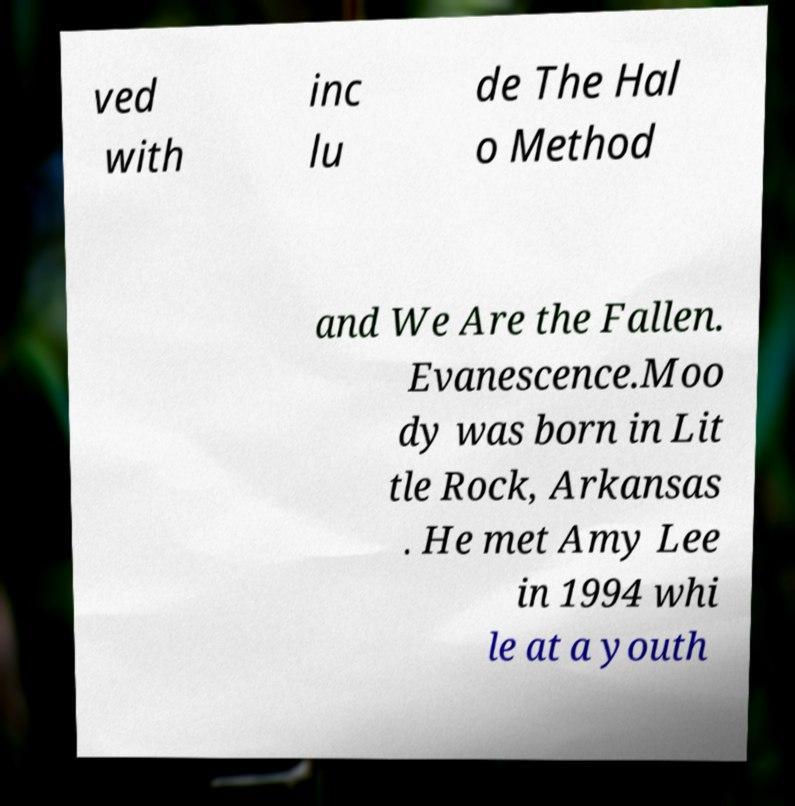I need the written content from this picture converted into text. Can you do that? ved with inc lu de The Hal o Method and We Are the Fallen. Evanescence.Moo dy was born in Lit tle Rock, Arkansas . He met Amy Lee in 1994 whi le at a youth 